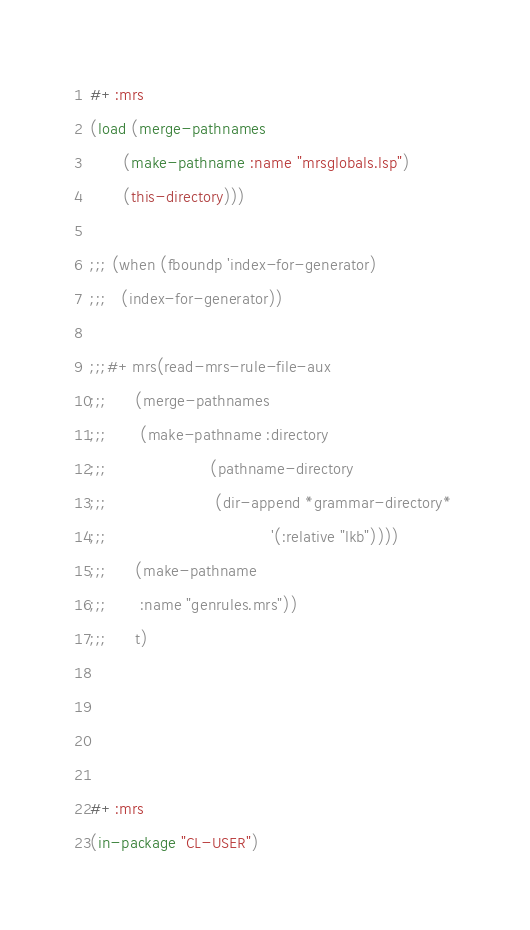Convert code to text. <code><loc_0><loc_0><loc_500><loc_500><_Lisp_>#+:mrs
(load (merge-pathnames
       (make-pathname :name "mrsglobals.lsp")
       (this-directory)))

;;; (when (fboundp 'index-for-generator)
;;;   (index-for-generator))

;;;#+mrs(read-mrs-rule-file-aux 
;;;      (merge-pathnames
;;;       (make-pathname :directory 
;;;                      (pathname-directory
;;;                       (dir-append *grammar-directory* 
;;;                                   '(:relative "lkb"))))
;;;      (make-pathname 
;;;       :name "genrules.mrs"))
;;;      t)




#+:mrs
(in-package "CL-USER")




</code> 